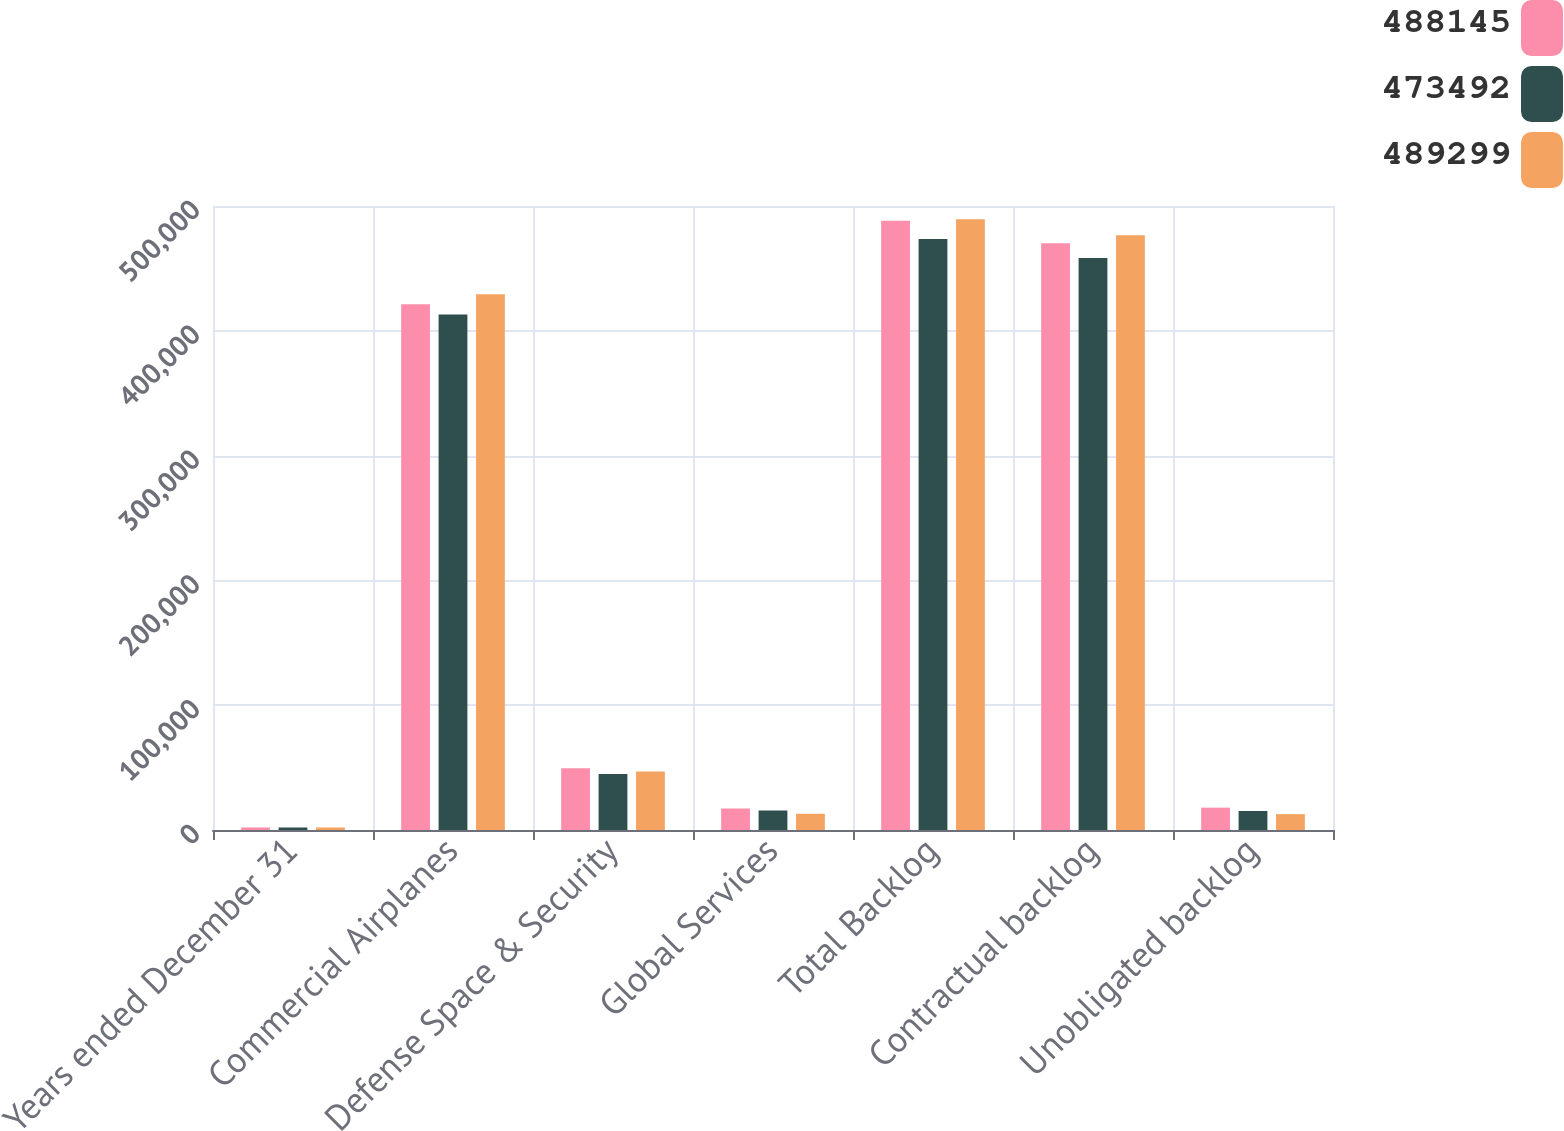Convert chart. <chart><loc_0><loc_0><loc_500><loc_500><stacked_bar_chart><ecel><fcel>Years ended December 31<fcel>Commercial Airplanes<fcel>Defense Space & Security<fcel>Global Services<fcel>Total Backlog<fcel>Contractual backlog<fcel>Unobligated backlog<nl><fcel>488145<fcel>2017<fcel>421345<fcel>49577<fcel>17223<fcel>488145<fcel>470241<fcel>17904<nl><fcel>473492<fcel>2016<fcel>413036<fcel>44825<fcel>15631<fcel>473492<fcel>458277<fcel>15215<nl><fcel>489299<fcel>2015<fcel>429346<fcel>46933<fcel>13020<fcel>489299<fcel>476595<fcel>12704<nl></chart> 